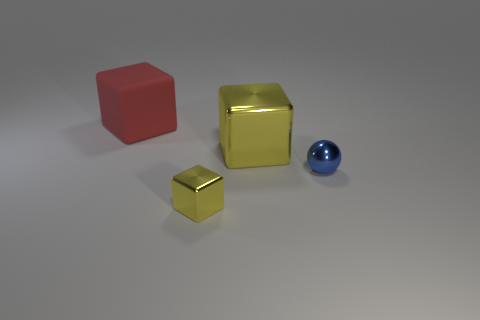There is another cube that is the same size as the rubber block; what is its material?
Keep it short and to the point. Metal. What number of other things are made of the same material as the large red object?
Make the answer very short. 0. There is a small shiny thing that is right of the big block to the right of the large red cube; what is its shape?
Provide a succinct answer. Sphere. How many things are either big metal things or objects that are on the left side of the blue sphere?
Make the answer very short. 3. How many other things are the same color as the large metallic block?
Give a very brief answer. 1. What number of brown objects are small blocks or big matte cubes?
Give a very brief answer. 0. Is there a metallic sphere that is left of the cube that is behind the big object that is in front of the rubber block?
Your answer should be very brief. No. Is there any other thing that has the same size as the red rubber object?
Make the answer very short. Yes. Does the metal ball have the same color as the small block?
Give a very brief answer. No. There is a tiny thing that is to the right of the yellow metal block that is behind the tiny blue object; what is its color?
Give a very brief answer. Blue. 